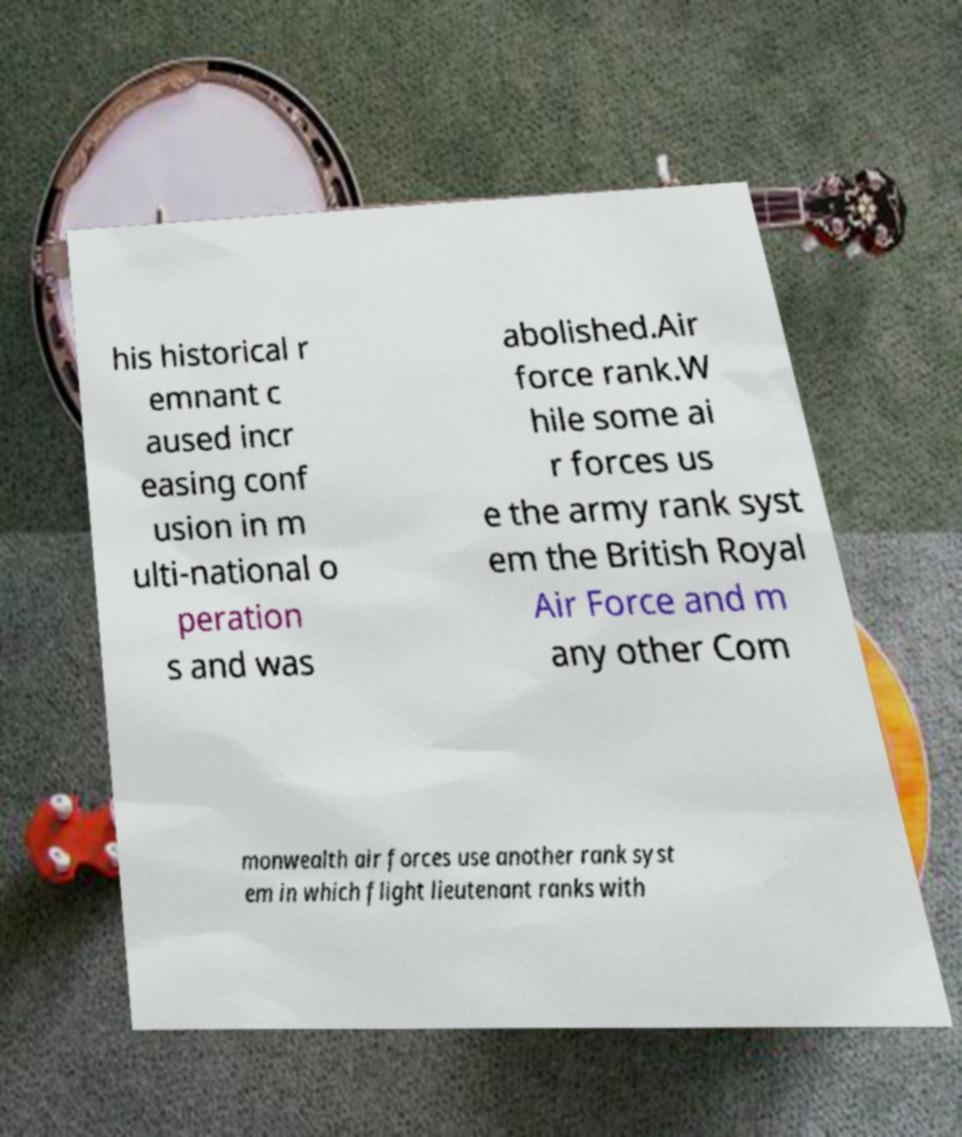Can you accurately transcribe the text from the provided image for me? his historical r emnant c aused incr easing conf usion in m ulti-national o peration s and was abolished.Air force rank.W hile some ai r forces us e the army rank syst em the British Royal Air Force and m any other Com monwealth air forces use another rank syst em in which flight lieutenant ranks with 